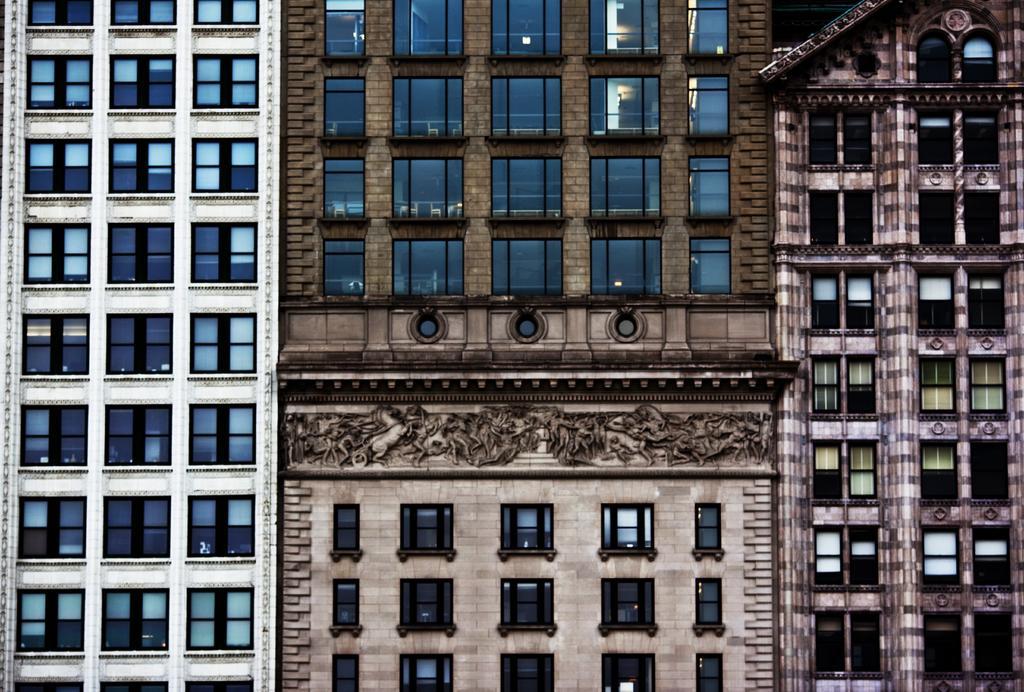Can you describe this image briefly? In this image I can see buildings and windows. This image is taken may be during a day. 